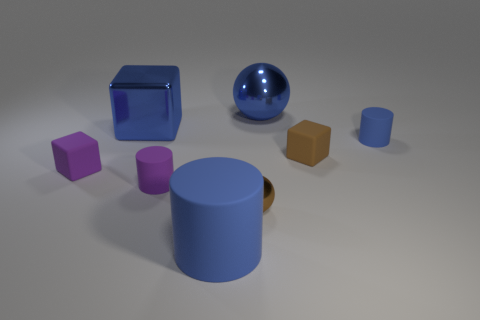There is a cylinder on the right side of the brown block; is its color the same as the big cylinder?
Offer a very short reply. Yes. There is a tiny rubber object that is the same color as the large sphere; what shape is it?
Provide a short and direct response. Cylinder. What number of cylinders are to the left of the small cylinder to the right of the blue sphere?
Make the answer very short. 2. How many other things are there of the same size as the purple cube?
Your response must be concise. 4. What number of things are either green things or rubber cubes that are on the left side of the tiny brown shiny ball?
Provide a succinct answer. 1. Is the number of small gray cylinders less than the number of tiny blue objects?
Make the answer very short. Yes. The small cylinder that is behind the matte cube that is on the right side of the blue metal sphere is what color?
Keep it short and to the point. Blue. There is a tiny blue thing that is the same shape as the big blue matte object; what material is it?
Give a very brief answer. Rubber. What number of rubber objects are either big yellow cylinders or purple cylinders?
Keep it short and to the point. 1. Does the big blue thing in front of the tiny brown metallic thing have the same material as the block behind the tiny brown matte object?
Give a very brief answer. No. 